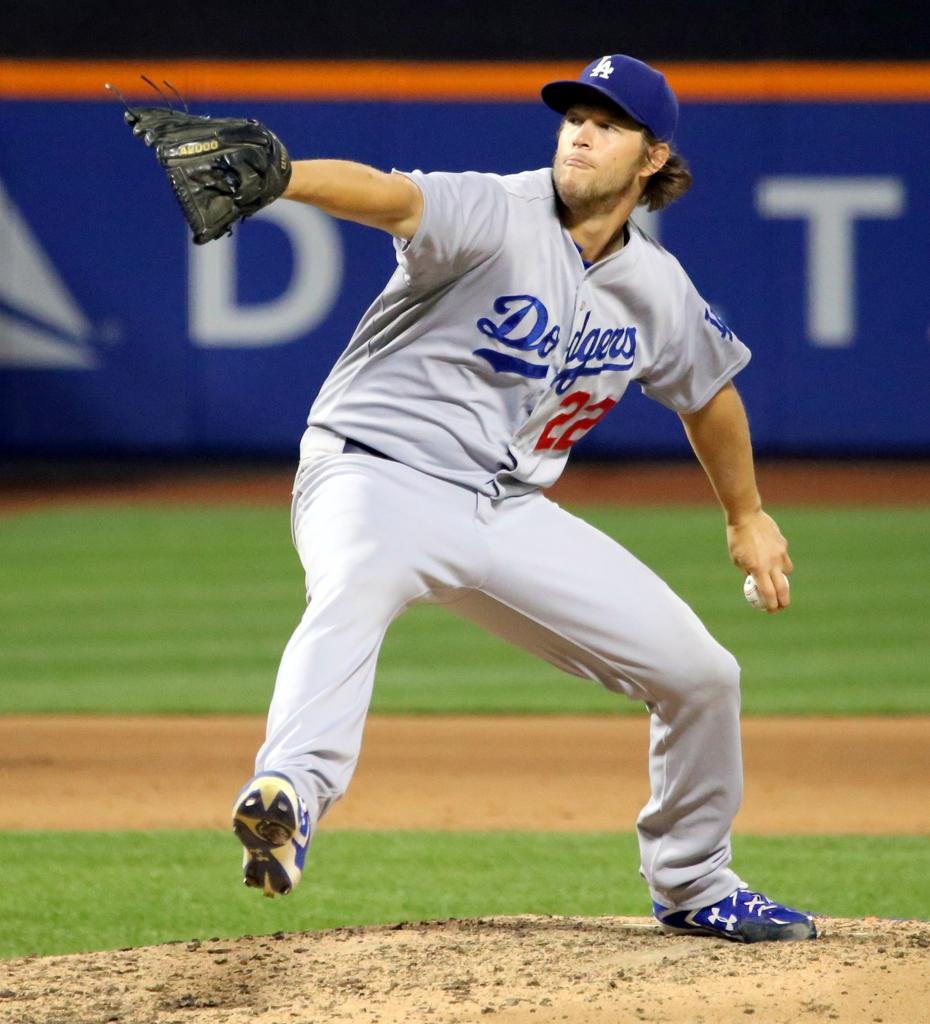What team does this player play for?
Provide a short and direct response. Dodgers. What number is written on the jersey?
Give a very brief answer. 22. 